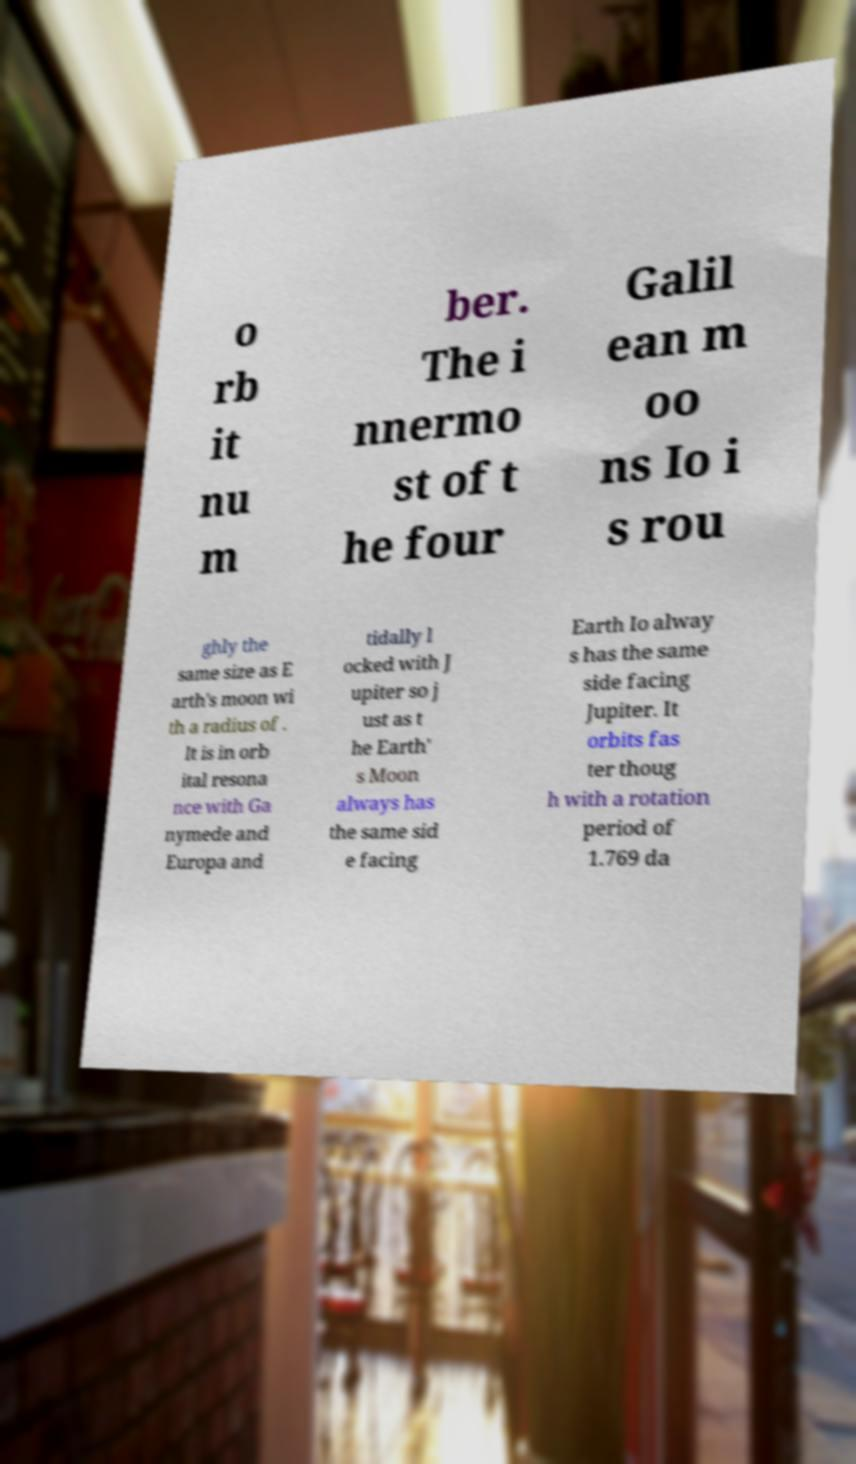What messages or text are displayed in this image? I need them in a readable, typed format. o rb it nu m ber. The i nnermo st of t he four Galil ean m oo ns Io i s rou ghly the same size as E arth's moon wi th a radius of . It is in orb ital resona nce with Ga nymede and Europa and tidally l ocked with J upiter so j ust as t he Earth' s Moon always has the same sid e facing Earth Io alway s has the same side facing Jupiter. It orbits fas ter thoug h with a rotation period of 1.769 da 